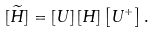Convert formula to latex. <formula><loc_0><loc_0><loc_500><loc_500>[ \widetilde { H } ] = \left [ U \right ] \left [ H \right ] \left [ U ^ { + } \right ] .</formula> 